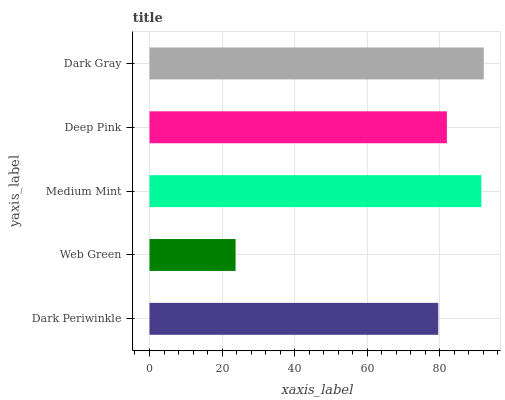Is Web Green the minimum?
Answer yes or no. Yes. Is Dark Gray the maximum?
Answer yes or no. Yes. Is Medium Mint the minimum?
Answer yes or no. No. Is Medium Mint the maximum?
Answer yes or no. No. Is Medium Mint greater than Web Green?
Answer yes or no. Yes. Is Web Green less than Medium Mint?
Answer yes or no. Yes. Is Web Green greater than Medium Mint?
Answer yes or no. No. Is Medium Mint less than Web Green?
Answer yes or no. No. Is Deep Pink the high median?
Answer yes or no. Yes. Is Deep Pink the low median?
Answer yes or no. Yes. Is Web Green the high median?
Answer yes or no. No. Is Web Green the low median?
Answer yes or no. No. 